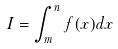Convert formula to latex. <formula><loc_0><loc_0><loc_500><loc_500>I = \int _ { m } ^ { n } f ( x ) d x</formula> 